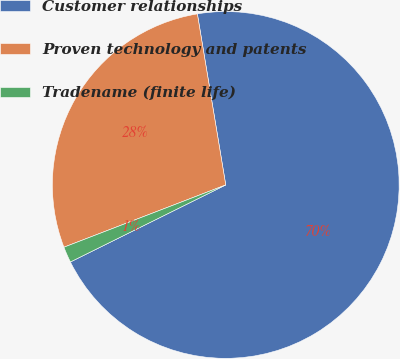Convert chart to OTSL. <chart><loc_0><loc_0><loc_500><loc_500><pie_chart><fcel>Customer relationships<fcel>Proven technology and patents<fcel>Tradename (finite life)<nl><fcel>70.29%<fcel>28.23%<fcel>1.48%<nl></chart> 